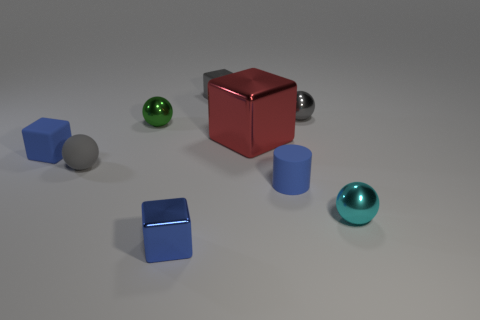Subtract all tiny gray rubber spheres. How many spheres are left? 3 Subtract all red cylinders. How many blue cubes are left? 2 Subtract 1 spheres. How many spheres are left? 3 Subtract all gray cubes. How many cubes are left? 3 Subtract all green blocks. Subtract all brown spheres. How many blocks are left? 4 Subtract all balls. How many objects are left? 5 Subtract all tiny purple blocks. Subtract all cubes. How many objects are left? 5 Add 5 big things. How many big things are left? 6 Add 7 large yellow metal cubes. How many large yellow metal cubes exist? 7 Subtract 0 purple spheres. How many objects are left? 9 